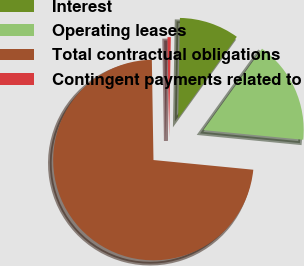Convert chart to OTSL. <chart><loc_0><loc_0><loc_500><loc_500><pie_chart><fcel>Interest<fcel>Operating leases<fcel>Total contractual obligations<fcel>Contingent payments related to<nl><fcel>9.66%<fcel>16.61%<fcel>73.2%<fcel>0.53%<nl></chart> 